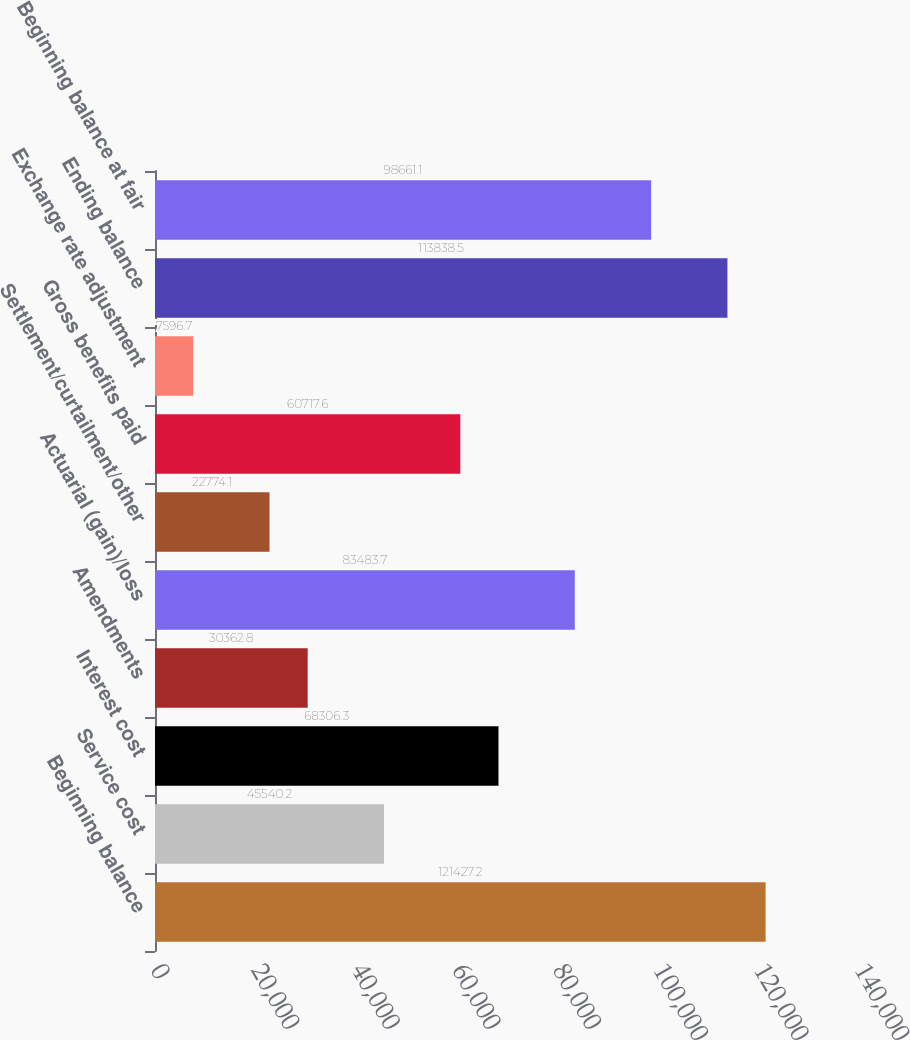<chart> <loc_0><loc_0><loc_500><loc_500><bar_chart><fcel>Beginning balance<fcel>Service cost<fcel>Interest cost<fcel>Amendments<fcel>Actuarial (gain)/loss<fcel>Settlement/curtailment/other<fcel>Gross benefits paid<fcel>Exchange rate adjustment<fcel>Ending balance<fcel>Beginning balance at fair<nl><fcel>121427<fcel>45540.2<fcel>68306.3<fcel>30362.8<fcel>83483.7<fcel>22774.1<fcel>60717.6<fcel>7596.7<fcel>113838<fcel>98661.1<nl></chart> 